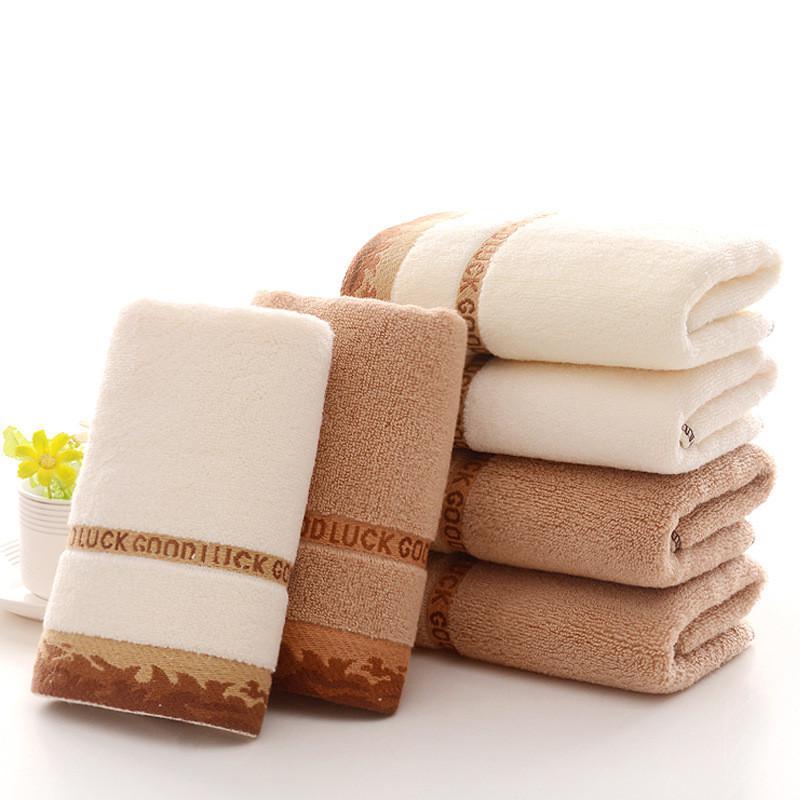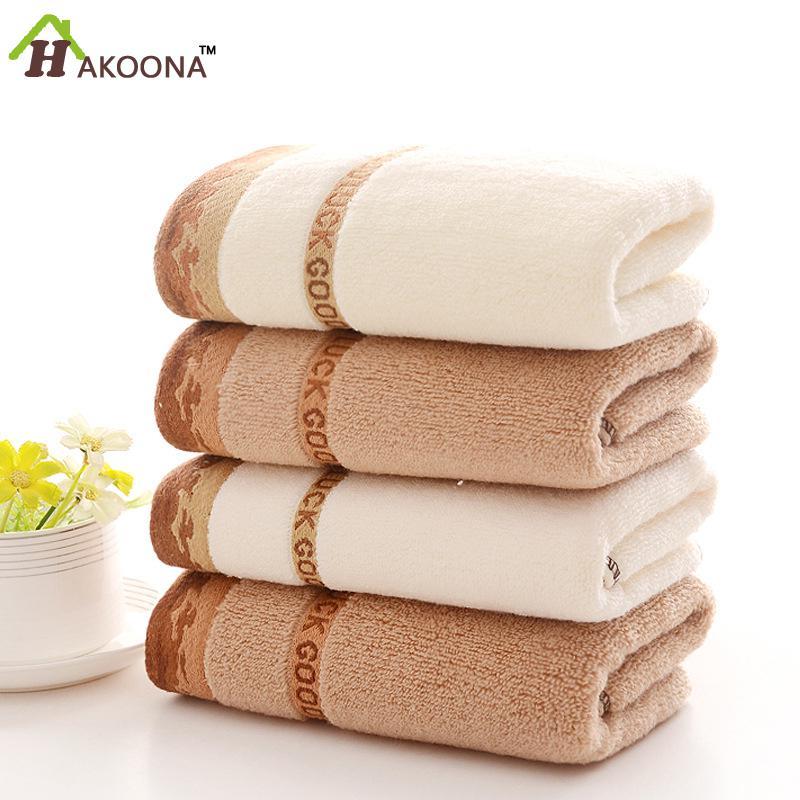The first image is the image on the left, the second image is the image on the right. Evaluate the accuracy of this statement regarding the images: "There is a towel draped over a basket in one of the images.". Is it true? Answer yes or no. No. 